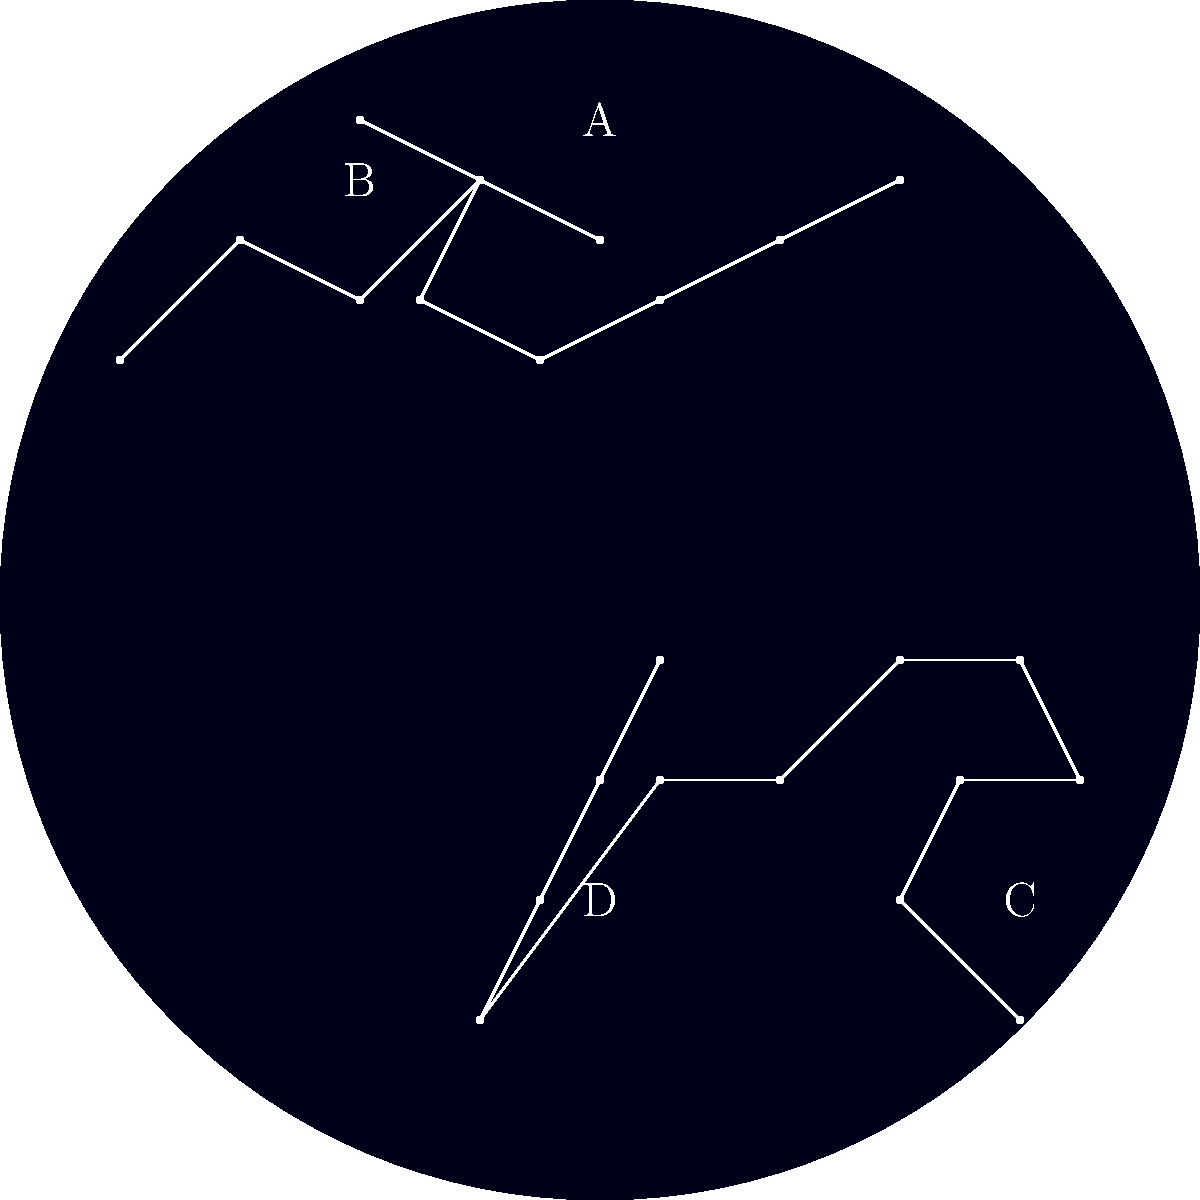Which constellation, labeled in the image, is known as the "Great Bear" and is visible year-round from your hunting cabin in northern Canada, serving as a reliable celestial landmark for navigation during nighttime treks? To answer this question, let's analyze each constellation in the image:

1. Constellation A: This is Ursa Major, also known as the "Great Bear." It has a distinctive shape often referred to as the "Big Dipper." Ursa Major is a circumpolar constellation, meaning it never sets below the horizon when viewed from northern latitudes like Canada.

2. Constellation B: This is Cassiopeia, recognizable by its W or M shape. While also circumpolar from Canada, it's not known as the "Great Bear."

3. Constellation C: This is Orion, identifiable by its "belt" of three stars in a row. Orion is not circumpolar and is primarily visible in winter months.

4. Constellation D: This is Cygnus, also known as the "Northern Cross." It's visible in summer and autumn but not year-round.

Given the question asks for a year-round visible constellation known as the "Great Bear," the correct answer is Ursa Major, labeled as A in the image. Its year-round visibility makes it an excellent navigation tool for nighttime hunting or trekking in the Canadian wilderness.
Answer: A (Ursa Major) 